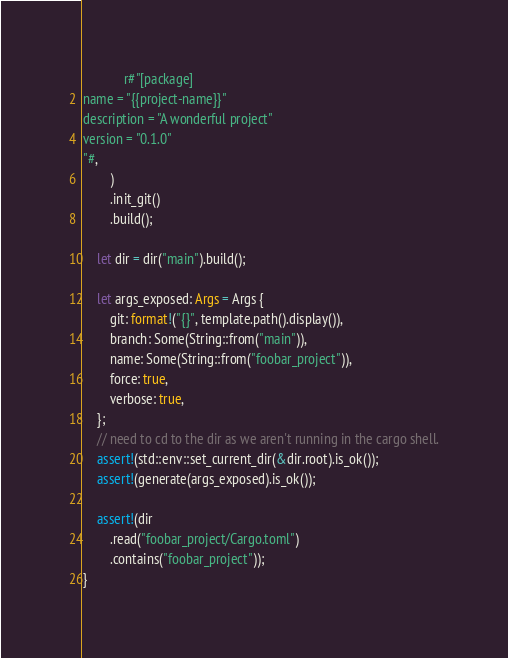Convert code to text. <code><loc_0><loc_0><loc_500><loc_500><_Rust_>            r#"[package]
name = "{{project-name}}"
description = "A wonderful project"
version = "0.1.0"
"#,
        )
        .init_git()
        .build();

    let dir = dir("main").build();

    let args_exposed: Args = Args {
        git: format!("{}", template.path().display()),
        branch: Some(String::from("main")),
        name: Some(String::from("foobar_project")),
        force: true,
        verbose: true,
    };
    // need to cd to the dir as we aren't running in the cargo shell.
    assert!(std::env::set_current_dir(&dir.root).is_ok());
    assert!(generate(args_exposed).is_ok());

    assert!(dir
        .read("foobar_project/Cargo.toml")
        .contains("foobar_project"));
}
</code> 